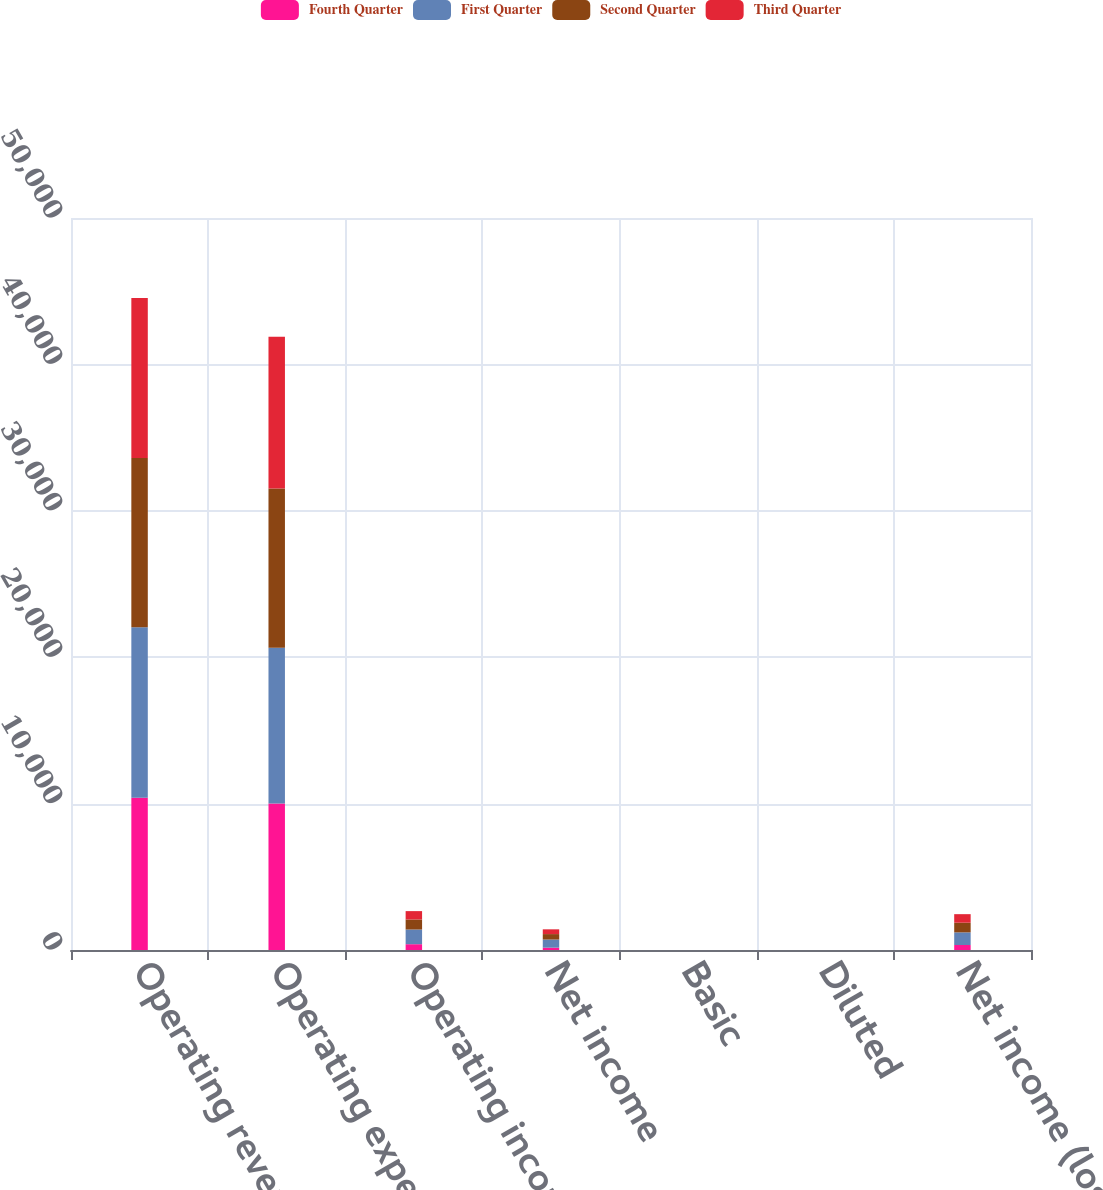<chart> <loc_0><loc_0><loc_500><loc_500><stacked_bar_chart><ecel><fcel>Operating revenues<fcel>Operating expenses<fcel>Operating income<fcel>Net income<fcel>Basic<fcel>Diluted<fcel>Net income (loss)<nl><fcel>Fourth Quarter<fcel>10401<fcel>10005<fcel>396<fcel>159<fcel>0.34<fcel>0.34<fcel>340<nl><fcel>First Quarter<fcel>11643<fcel>10639<fcel>1004<fcel>556<fcel>1.2<fcel>1.2<fcel>864<nl><fcel>Second Quarter<fcel>11559<fcel>10874<fcel>685<fcel>372<fcel>0.81<fcel>0.81<fcel>661<nl><fcel>Third Quarter<fcel>10938<fcel>10367<fcel>571<fcel>325<fcel>0.71<fcel>0.7<fcel>583<nl></chart> 